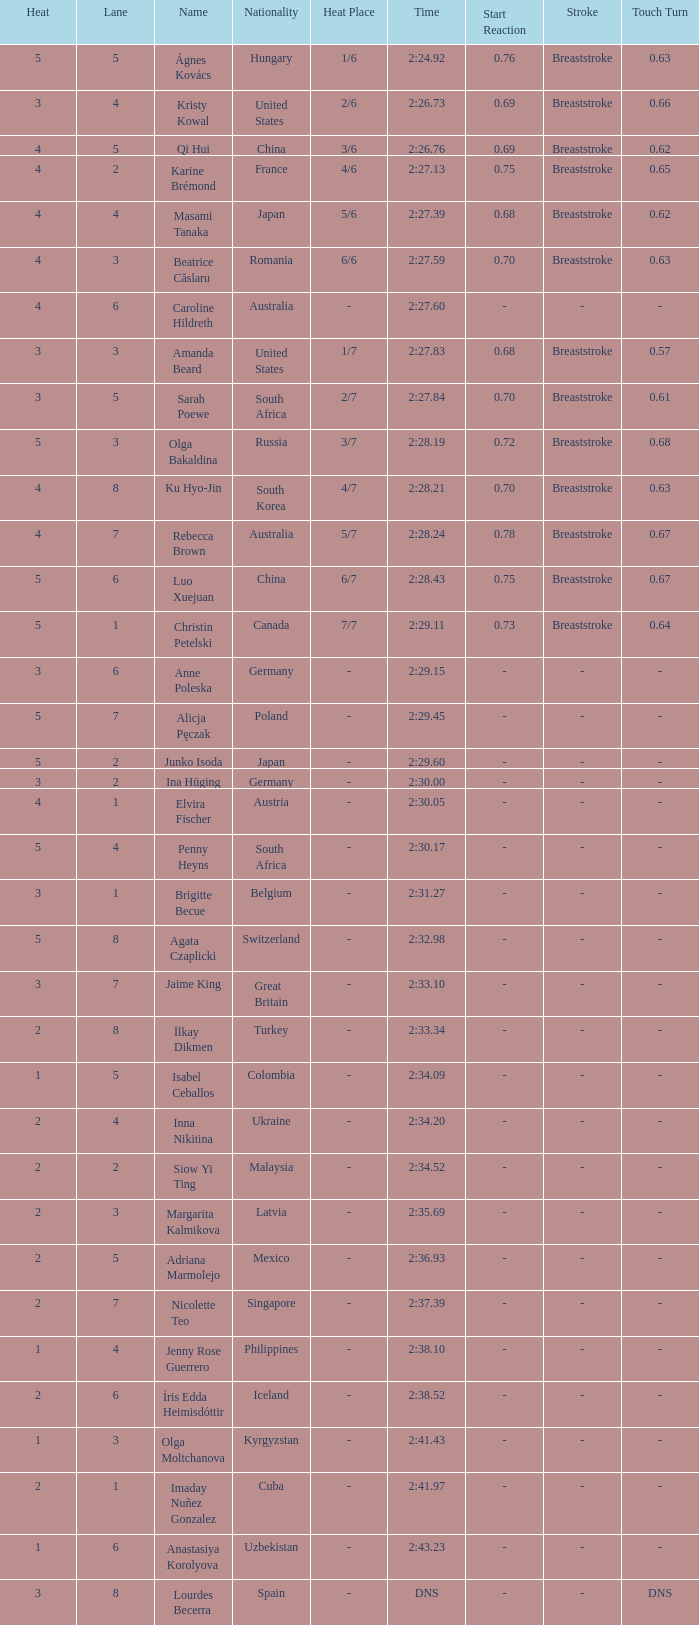What is the name that saw 4 heats and a lane higher than 7? Ku Hyo-Jin. Parse the full table. {'header': ['Heat', 'Lane', 'Name', 'Nationality', 'Heat Place', 'Time', 'Start Reaction', 'Stroke', 'Touch Turn'], 'rows': [['5', '5', 'Ágnes Kovács', 'Hungary', '1/6', '2:24.92', '0.76', 'Breaststroke', '0.63'], ['3', '4', 'Kristy Kowal', 'United States', '2/6', '2:26.73', '0.69', 'Breaststroke', '0.66'], ['4', '5', 'Qi Hui', 'China', '3/6', '2:26.76', '0.69', 'Breaststroke', '0.62'], ['4', '2', 'Karine Brémond', 'France', '4/6', '2:27.13', '0.75', 'Breaststroke', '0.65'], ['4', '4', 'Masami Tanaka', 'Japan', '5/6', '2:27.39', '0.68', 'Breaststroke', '0.62'], ['4', '3', 'Beatrice Căslaru', 'Romania', '6/6', '2:27.59', '0.70', 'Breaststroke', '0.63'], ['4', '6', 'Caroline Hildreth', 'Australia', '-', '2:27.60', '-', '-', '-'], ['3', '3', 'Amanda Beard', 'United States', '1/7', '2:27.83', '0.68', 'Breaststroke', '0.57'], ['3', '5', 'Sarah Poewe', 'South Africa', '2/7', '2:27.84', '0.70', 'Breaststroke', '0.61'], ['5', '3', 'Olga Bakaldina', 'Russia', '3/7', '2:28.19', '0.72', 'Breaststroke', '0.68'], ['4', '8', 'Ku Hyo-Jin', 'South Korea', '4/7', '2:28.21', '0.70', 'Breaststroke', '0.63'], ['4', '7', 'Rebecca Brown', 'Australia', '5/7', '2:28.24', '0.78', 'Breaststroke', '0.67'], ['5', '6', 'Luo Xuejuan', 'China', '6/7', '2:28.43', '0.75', 'Breaststroke', '0.67'], ['5', '1', 'Christin Petelski', 'Canada', '7/7', '2:29.11', '0.73', 'Breaststroke', '0.64'], ['3', '6', 'Anne Poleska', 'Germany', '-', '2:29.15', '-', '-', '-'], ['5', '7', 'Alicja Pęczak', 'Poland', '-', '2:29.45', '-', '-', '-'], ['5', '2', 'Junko Isoda', 'Japan', '-', '2:29.60', '-', '-', '-'], ['3', '2', 'Ina Hüging', 'Germany', '-', '2:30.00', '-', '-', '-'], ['4', '1', 'Elvira Fischer', 'Austria', '-', '2:30.05', '-', '-', '-'], ['5', '4', 'Penny Heyns', 'South Africa', '-', '2:30.17', '-', '-', '-'], ['3', '1', 'Brigitte Becue', 'Belgium', '-', '2:31.27', '-', '-', '-'], ['5', '8', 'Agata Czaplicki', 'Switzerland', '-', '2:32.98', '-', '-', '-'], ['3', '7', 'Jaime King', 'Great Britain', '-', '2:33.10', '-', '-', '-'], ['2', '8', 'İlkay Dikmen', 'Turkey', '-', '2:33.34', '-', '-', '-'], ['1', '5', 'Isabel Ceballos', 'Colombia', '-', '2:34.09', '-', '-', '-'], ['2', '4', 'Inna Nikitina', 'Ukraine', '-', '2:34.20', '-', '-', '-'], ['2', '2', 'Siow Yi Ting', 'Malaysia', '-', '2:34.52', '-', '-', '-'], ['2', '3', 'Margarita Kalmikova', 'Latvia', '-', '2:35.69', '-', '-', '-'], ['2', '5', 'Adriana Marmolejo', 'Mexico', '-', '2:36.93', '-', '-', '-'], ['2', '7', 'Nicolette Teo', 'Singapore', '-', '2:37.39', '-', '-', '-'], ['1', '4', 'Jenny Rose Guerrero', 'Philippines', '-', '2:38.10', '-', '-', '-'], ['2', '6', 'Íris Edda Heimisdóttir', 'Iceland', '-', '2:38.52', '-', '-', '-'], ['1', '3', 'Olga Moltchanova', 'Kyrgyzstan', '-', '2:41.43', '-', '-', '-'], ['2', '1', 'Imaday Nuñez Gonzalez', 'Cuba', '-', '2:41.97', '-', '-', '-'], ['1', '6', 'Anastasiya Korolyova', 'Uzbekistan', '-', '2:43.23', '-', '-', '-'], ['3', '8', 'Lourdes Becerra', 'Spain', '-', 'DNS', '-', '-', 'DNS']]} 